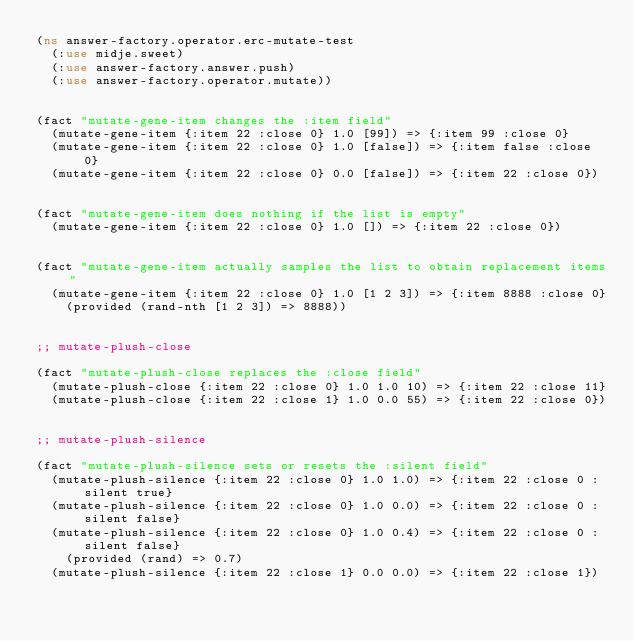<code> <loc_0><loc_0><loc_500><loc_500><_Clojure_>(ns answer-factory.operator.erc-mutate-test
  (:use midje.sweet)
  (:use answer-factory.answer.push)
  (:use answer-factory.operator.mutate))


(fact "mutate-gene-item changes the :item field"
  (mutate-gene-item {:item 22 :close 0} 1.0 [99]) => {:item 99 :close 0}
  (mutate-gene-item {:item 22 :close 0} 1.0 [false]) => {:item false :close 0}
  (mutate-gene-item {:item 22 :close 0} 0.0 [false]) => {:item 22 :close 0})


(fact "mutate-gene-item does nothing if the list is empty"
  (mutate-gene-item {:item 22 :close 0} 1.0 []) => {:item 22 :close 0})


(fact "mutate-gene-item actually samples the list to obtain replacement items"
  (mutate-gene-item {:item 22 :close 0} 1.0 [1 2 3]) => {:item 8888 :close 0}
    (provided (rand-nth [1 2 3]) => 8888))


;; mutate-plush-close

(fact "mutate-plush-close replaces the :close field"
  (mutate-plush-close {:item 22 :close 0} 1.0 1.0 10) => {:item 22 :close 11}
  (mutate-plush-close {:item 22 :close 1} 1.0 0.0 55) => {:item 22 :close 0})


;; mutate-plush-silence

(fact "mutate-plush-silence sets or resets the :silent field"
  (mutate-plush-silence {:item 22 :close 0} 1.0 1.0) => {:item 22 :close 0 :silent true}
  (mutate-plush-silence {:item 22 :close 0} 1.0 0.0) => {:item 22 :close 0 :silent false}
  (mutate-plush-silence {:item 22 :close 0} 1.0 0.4) => {:item 22 :close 0 :silent false}
    (provided (rand) => 0.7)
  (mutate-plush-silence {:item 22 :close 1} 0.0 0.0) => {:item 22 :close 1})
</code> 